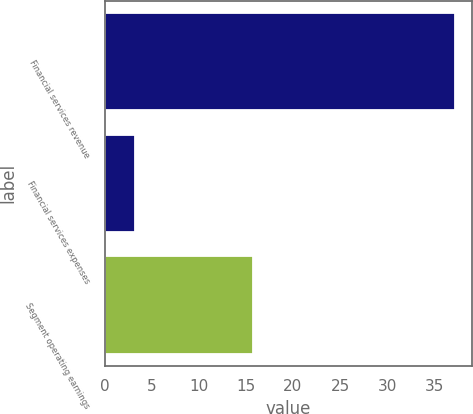Convert chart. <chart><loc_0><loc_0><loc_500><loc_500><bar_chart><fcel>Financial services revenue<fcel>Financial services expenses<fcel>Segment operating earnings<nl><fcel>37.18<fcel>3.2<fcel>15.8<nl></chart> 